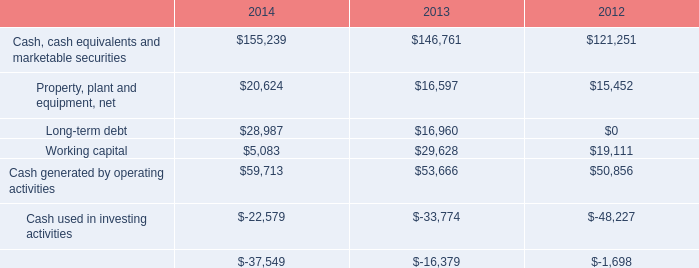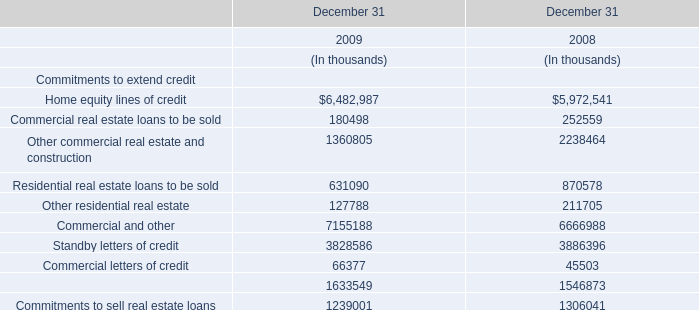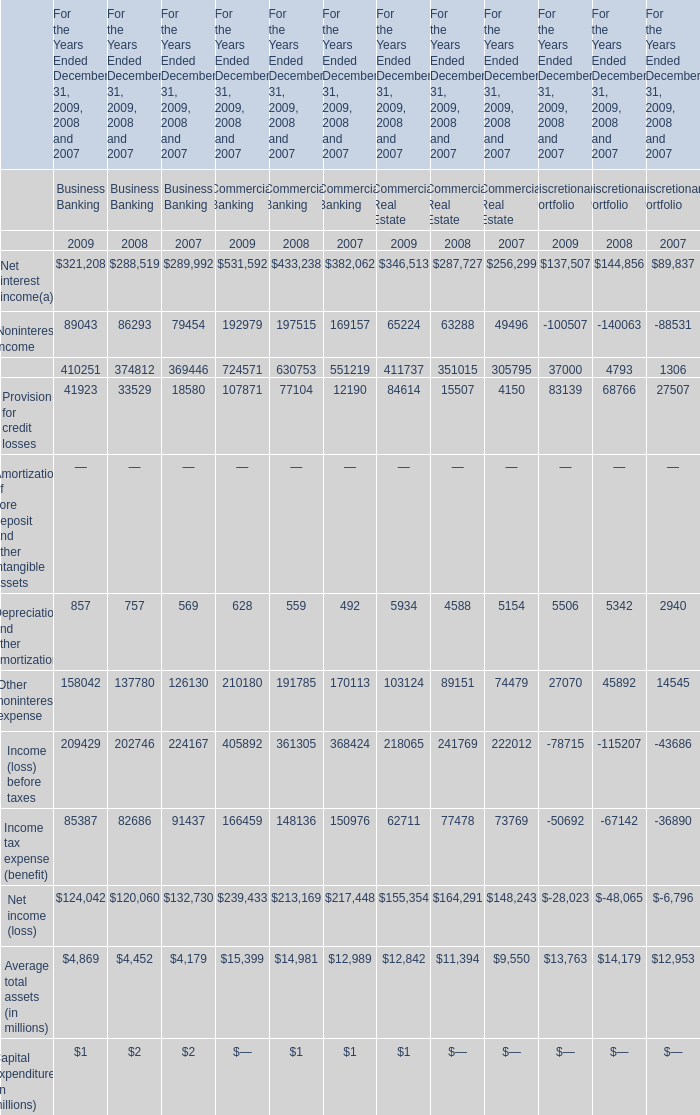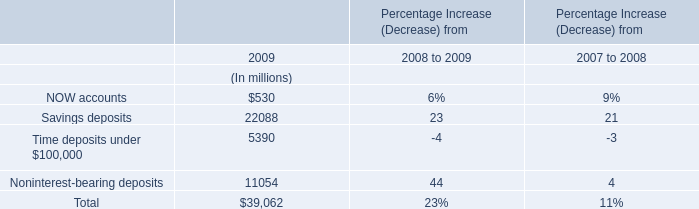In the year with largest value of Other noninterest expense for Commercial Banking, what's the increasing rate of Depreciation and other amortization for Commercial Banking? 
Computations: ((628 - 559) / 559)
Answer: 0.12343. 